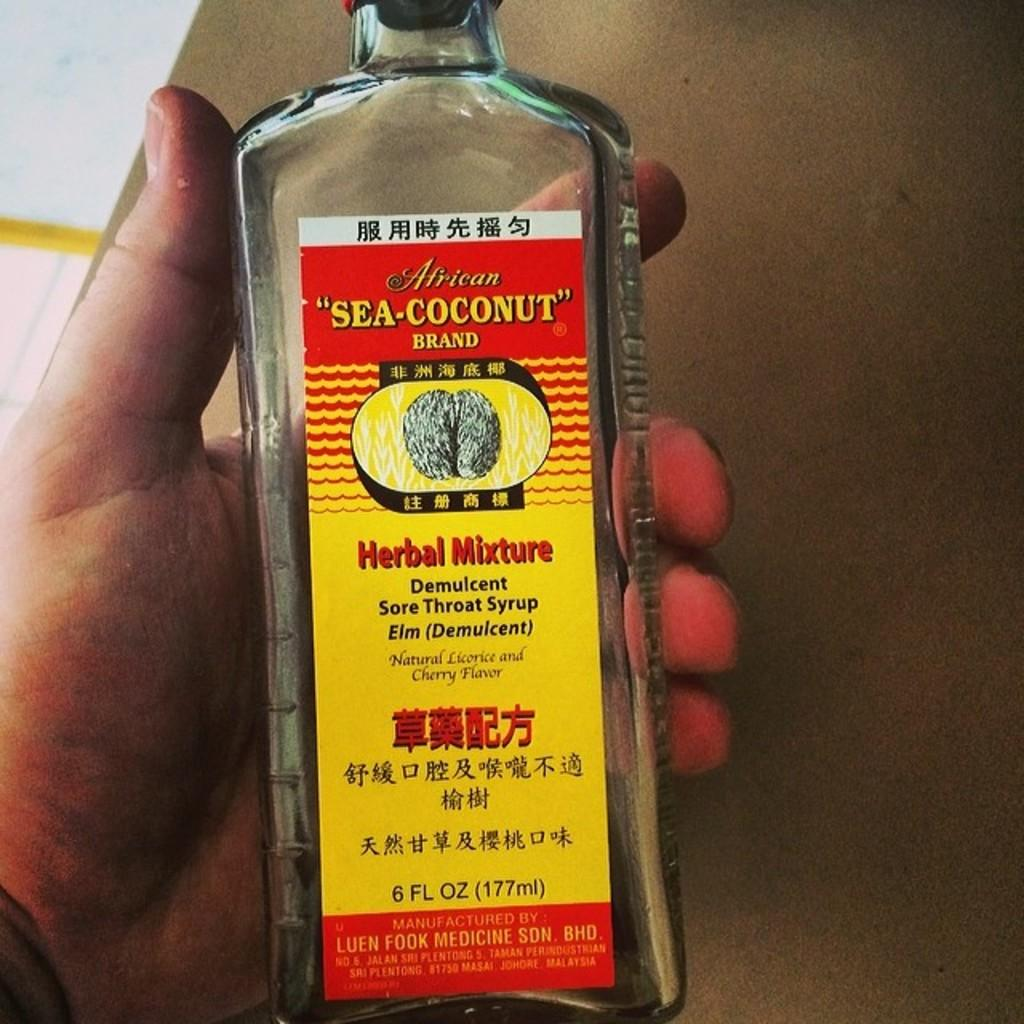<image>
Offer a succinct explanation of the picture presented. the word coconut is on the front of the bottle 